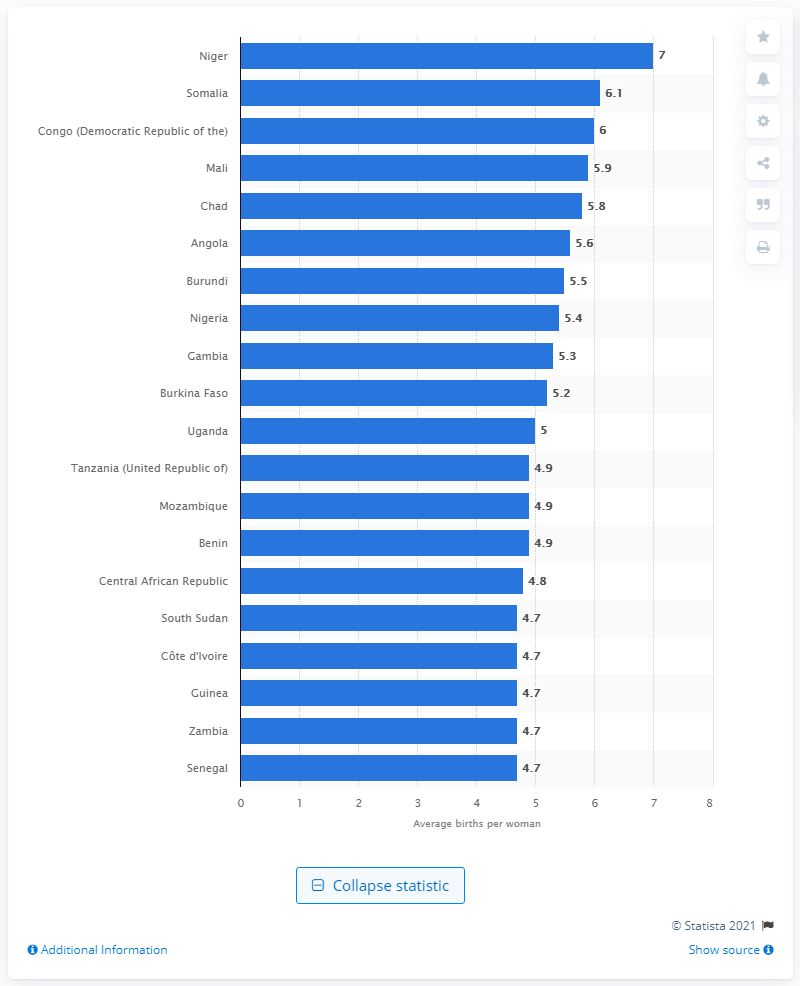Can you tell me more about the countries featured in this bar chart? Certainly! The countries featured in this bar chart are primarily located in Africa. They include nations with notably high fertility rates and reflect data that typically correlates with various socio-economic indicators such as healthcare access, educational attainment, and economic development. 